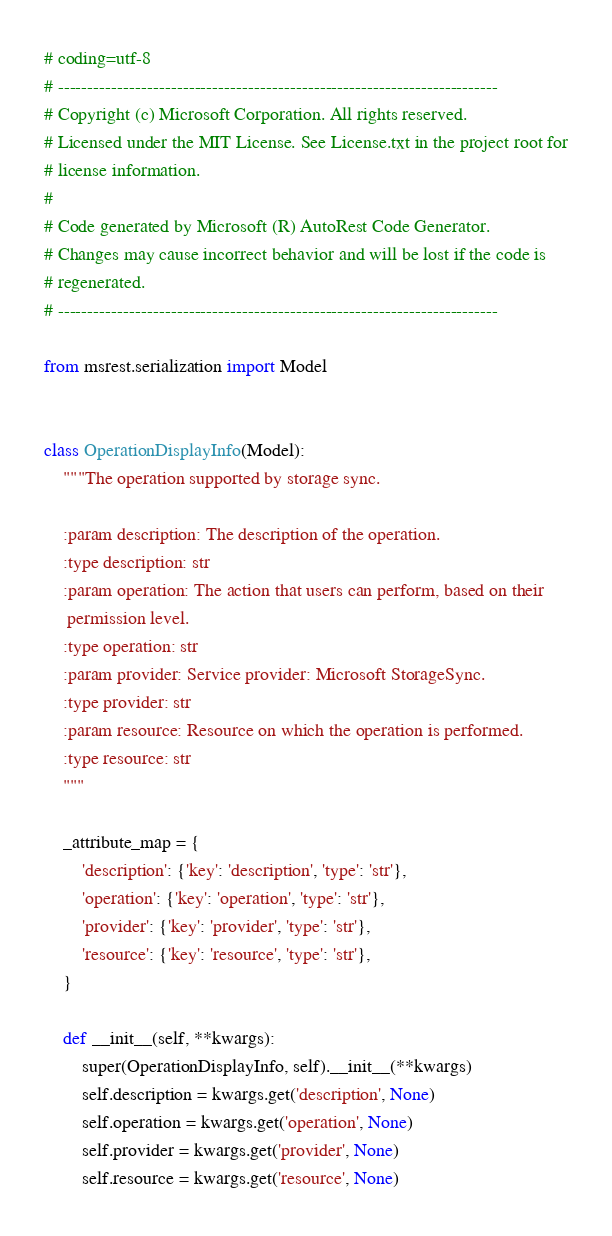<code> <loc_0><loc_0><loc_500><loc_500><_Python_># coding=utf-8
# --------------------------------------------------------------------------
# Copyright (c) Microsoft Corporation. All rights reserved.
# Licensed under the MIT License. See License.txt in the project root for
# license information.
#
# Code generated by Microsoft (R) AutoRest Code Generator.
# Changes may cause incorrect behavior and will be lost if the code is
# regenerated.
# --------------------------------------------------------------------------

from msrest.serialization import Model


class OperationDisplayInfo(Model):
    """The operation supported by storage sync.

    :param description: The description of the operation.
    :type description: str
    :param operation: The action that users can perform, based on their
     permission level.
    :type operation: str
    :param provider: Service provider: Microsoft StorageSync.
    :type provider: str
    :param resource: Resource on which the operation is performed.
    :type resource: str
    """

    _attribute_map = {
        'description': {'key': 'description', 'type': 'str'},
        'operation': {'key': 'operation', 'type': 'str'},
        'provider': {'key': 'provider', 'type': 'str'},
        'resource': {'key': 'resource', 'type': 'str'},
    }

    def __init__(self, **kwargs):
        super(OperationDisplayInfo, self).__init__(**kwargs)
        self.description = kwargs.get('description', None)
        self.operation = kwargs.get('operation', None)
        self.provider = kwargs.get('provider', None)
        self.resource = kwargs.get('resource', None)
</code> 